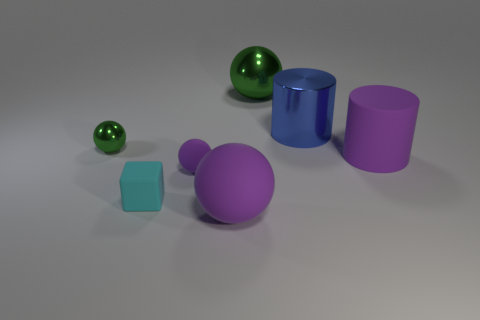Subtract all blue cylinders. How many green spheres are left? 2 Subtract all large purple matte spheres. How many spheres are left? 3 Subtract 1 spheres. How many spheres are left? 3 Add 3 large blue shiny cylinders. How many objects exist? 10 Subtract all blocks. How many objects are left? 6 Subtract all blue balls. Subtract all red cylinders. How many balls are left? 4 Subtract all gray cubes. Subtract all small cyan rubber blocks. How many objects are left? 6 Add 2 blue things. How many blue things are left? 3 Add 5 cyan rubber cylinders. How many cyan rubber cylinders exist? 5 Subtract 1 purple cylinders. How many objects are left? 6 